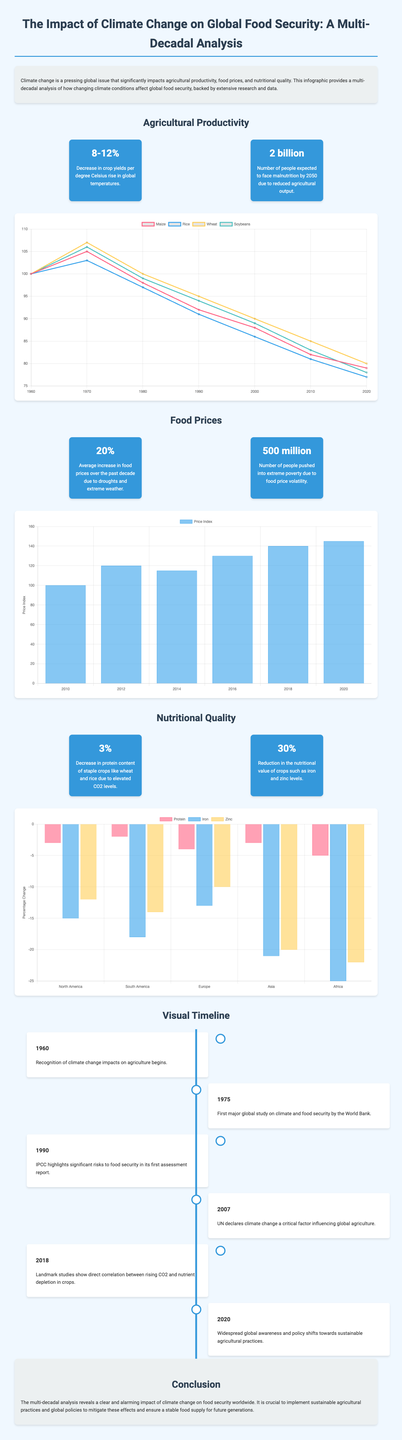what is the expected decrease in crop yields per degree Celsius rise in global temperatures? The expected decrease in crop yields is outlined in the statistics section of the infographic, specifically stating 8-12%.
Answer: 8-12% how many people are predicted to face malnutrition by 2050? The infographic states that around 2 billion people are expected to face malnutrition by 2050 due to reduced agricultural output.
Answer: 2 billion what was the average increase in food prices over the past decade due to climate-related issues? This statistic is provided under the food prices section, noting a 20% average increase attributed to droughts and extreme weather.
Answer: 20% what notable event regarding climate change and agriculture recognition happened in 1960? The timeline section mentions that recognition of climate change impacts on agriculture began in 1960.
Answer: Recognition began which crop experienced a yield decline to 79% by 2020 according to the crop yield chart? The crop yield chart specifically shows that maize yield declined to 79% by 2020.
Answer: Maize what percentage decrease in protein content is noted for staple crops due to elevated CO2 levels? The infographic quantifies a 3% decrease in protein content of staple crops like wheat and rice due to elevated CO2 levels.
Answer: 3% which decade saw the first major global study on climate and food security? The timeline indicates that the first major global study on climate and food security was conducted in 1975.
Answer: 1975 what is the conclusion regarding the impact of climate change on food security? The conclusion emphasizes the alarming impact of climate change on global food security and the importance of sustainable practices.
Answer: Alarming impact 